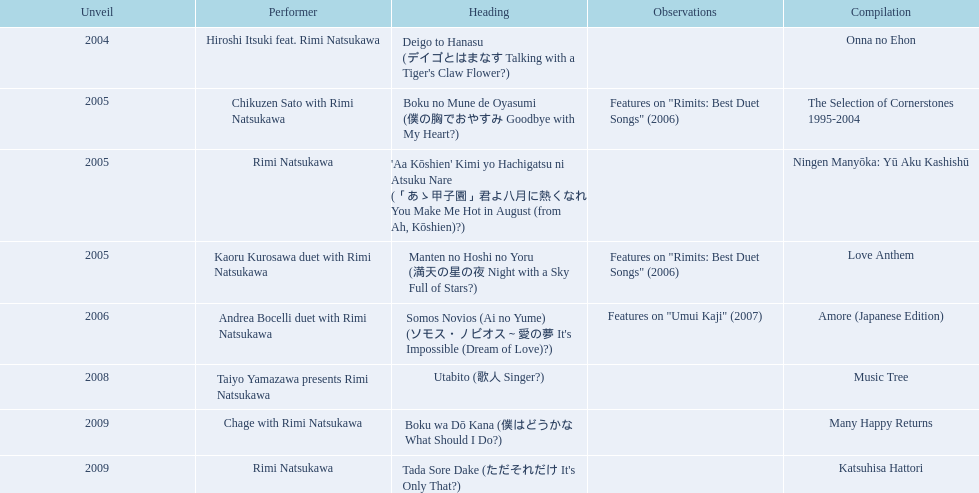What are the names of each album by rimi natsukawa? Onna no Ehon, The Selection of Cornerstones 1995-2004, Ningen Manyōka: Yū Aku Kashishū, Love Anthem, Amore (Japanese Edition), Music Tree, Many Happy Returns, Katsuhisa Hattori. And when were the albums released? 2004, 2005, 2005, 2005, 2006, 2008, 2009, 2009. Was onna no ehon or music tree released most recently? Music Tree. 